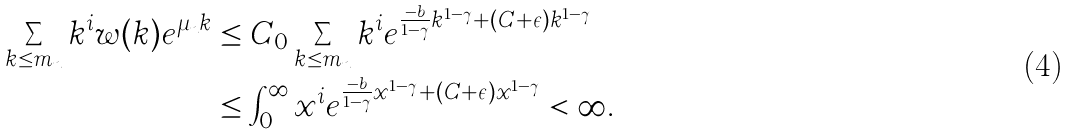Convert formula to latex. <formula><loc_0><loc_0><loc_500><loc_500>\sum _ { k \leq m _ { n } } k ^ { i } w ( k ) e ^ { \mu _ { n } k } & \leq C _ { 0 } \sum _ { k \leq m _ { n } } k ^ { i } e ^ { \frac { - b } { 1 - \gamma } k ^ { 1 - \gamma } + ( C + \epsilon ) k ^ { 1 - \gamma } } \\ & \leq \int _ { 0 } ^ { \infty } x ^ { i } e ^ { \frac { - b } { 1 - \gamma } x ^ { 1 - \gamma } + ( C + \epsilon ) x ^ { 1 - \gamma } } < \infty .</formula> 